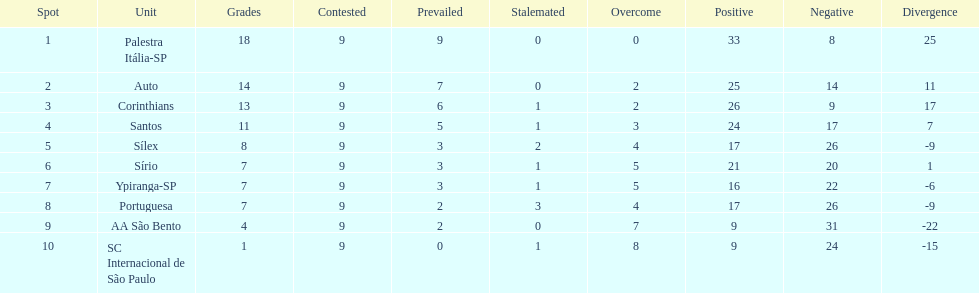Which team was the top scoring team? Palestra Itália-SP. 